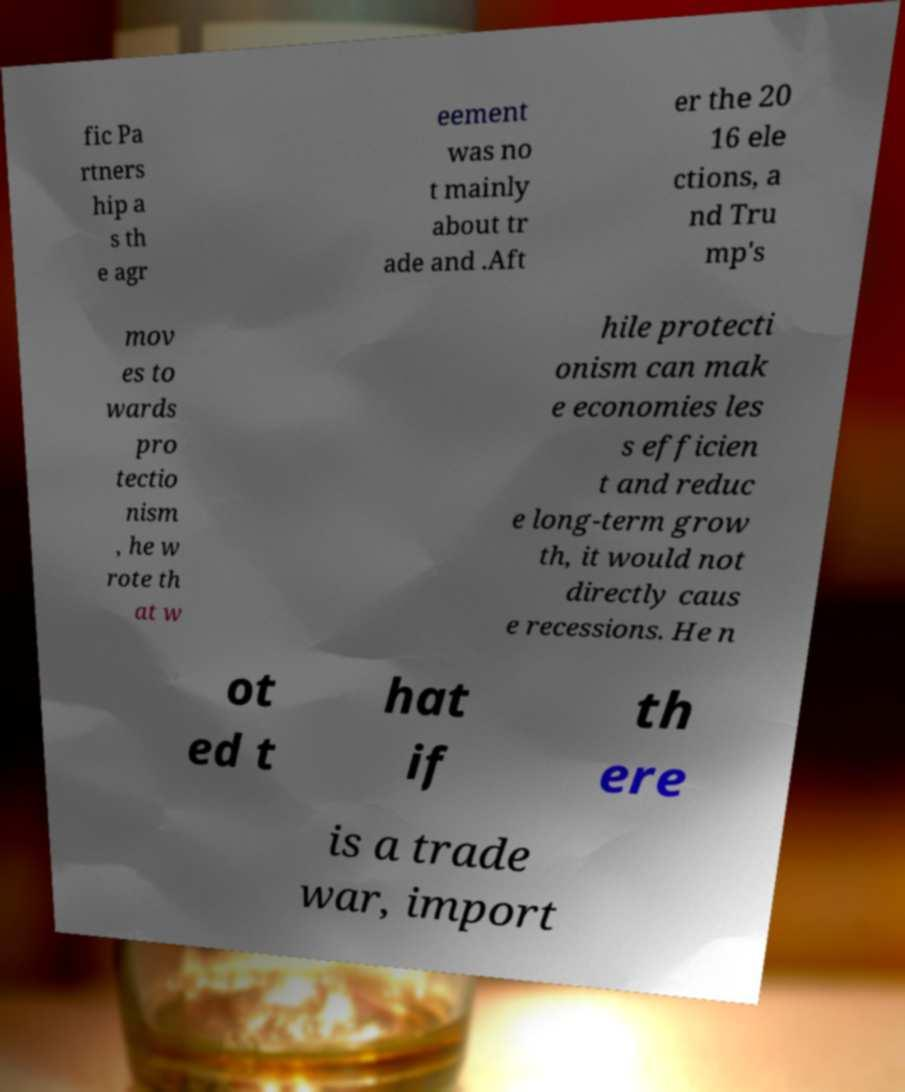Could you assist in decoding the text presented in this image and type it out clearly? fic Pa rtners hip a s th e agr eement was no t mainly about tr ade and .Aft er the 20 16 ele ctions, a nd Tru mp's mov es to wards pro tectio nism , he w rote th at w hile protecti onism can mak e economies les s efficien t and reduc e long-term grow th, it would not directly caus e recessions. He n ot ed t hat if th ere is a trade war, import 